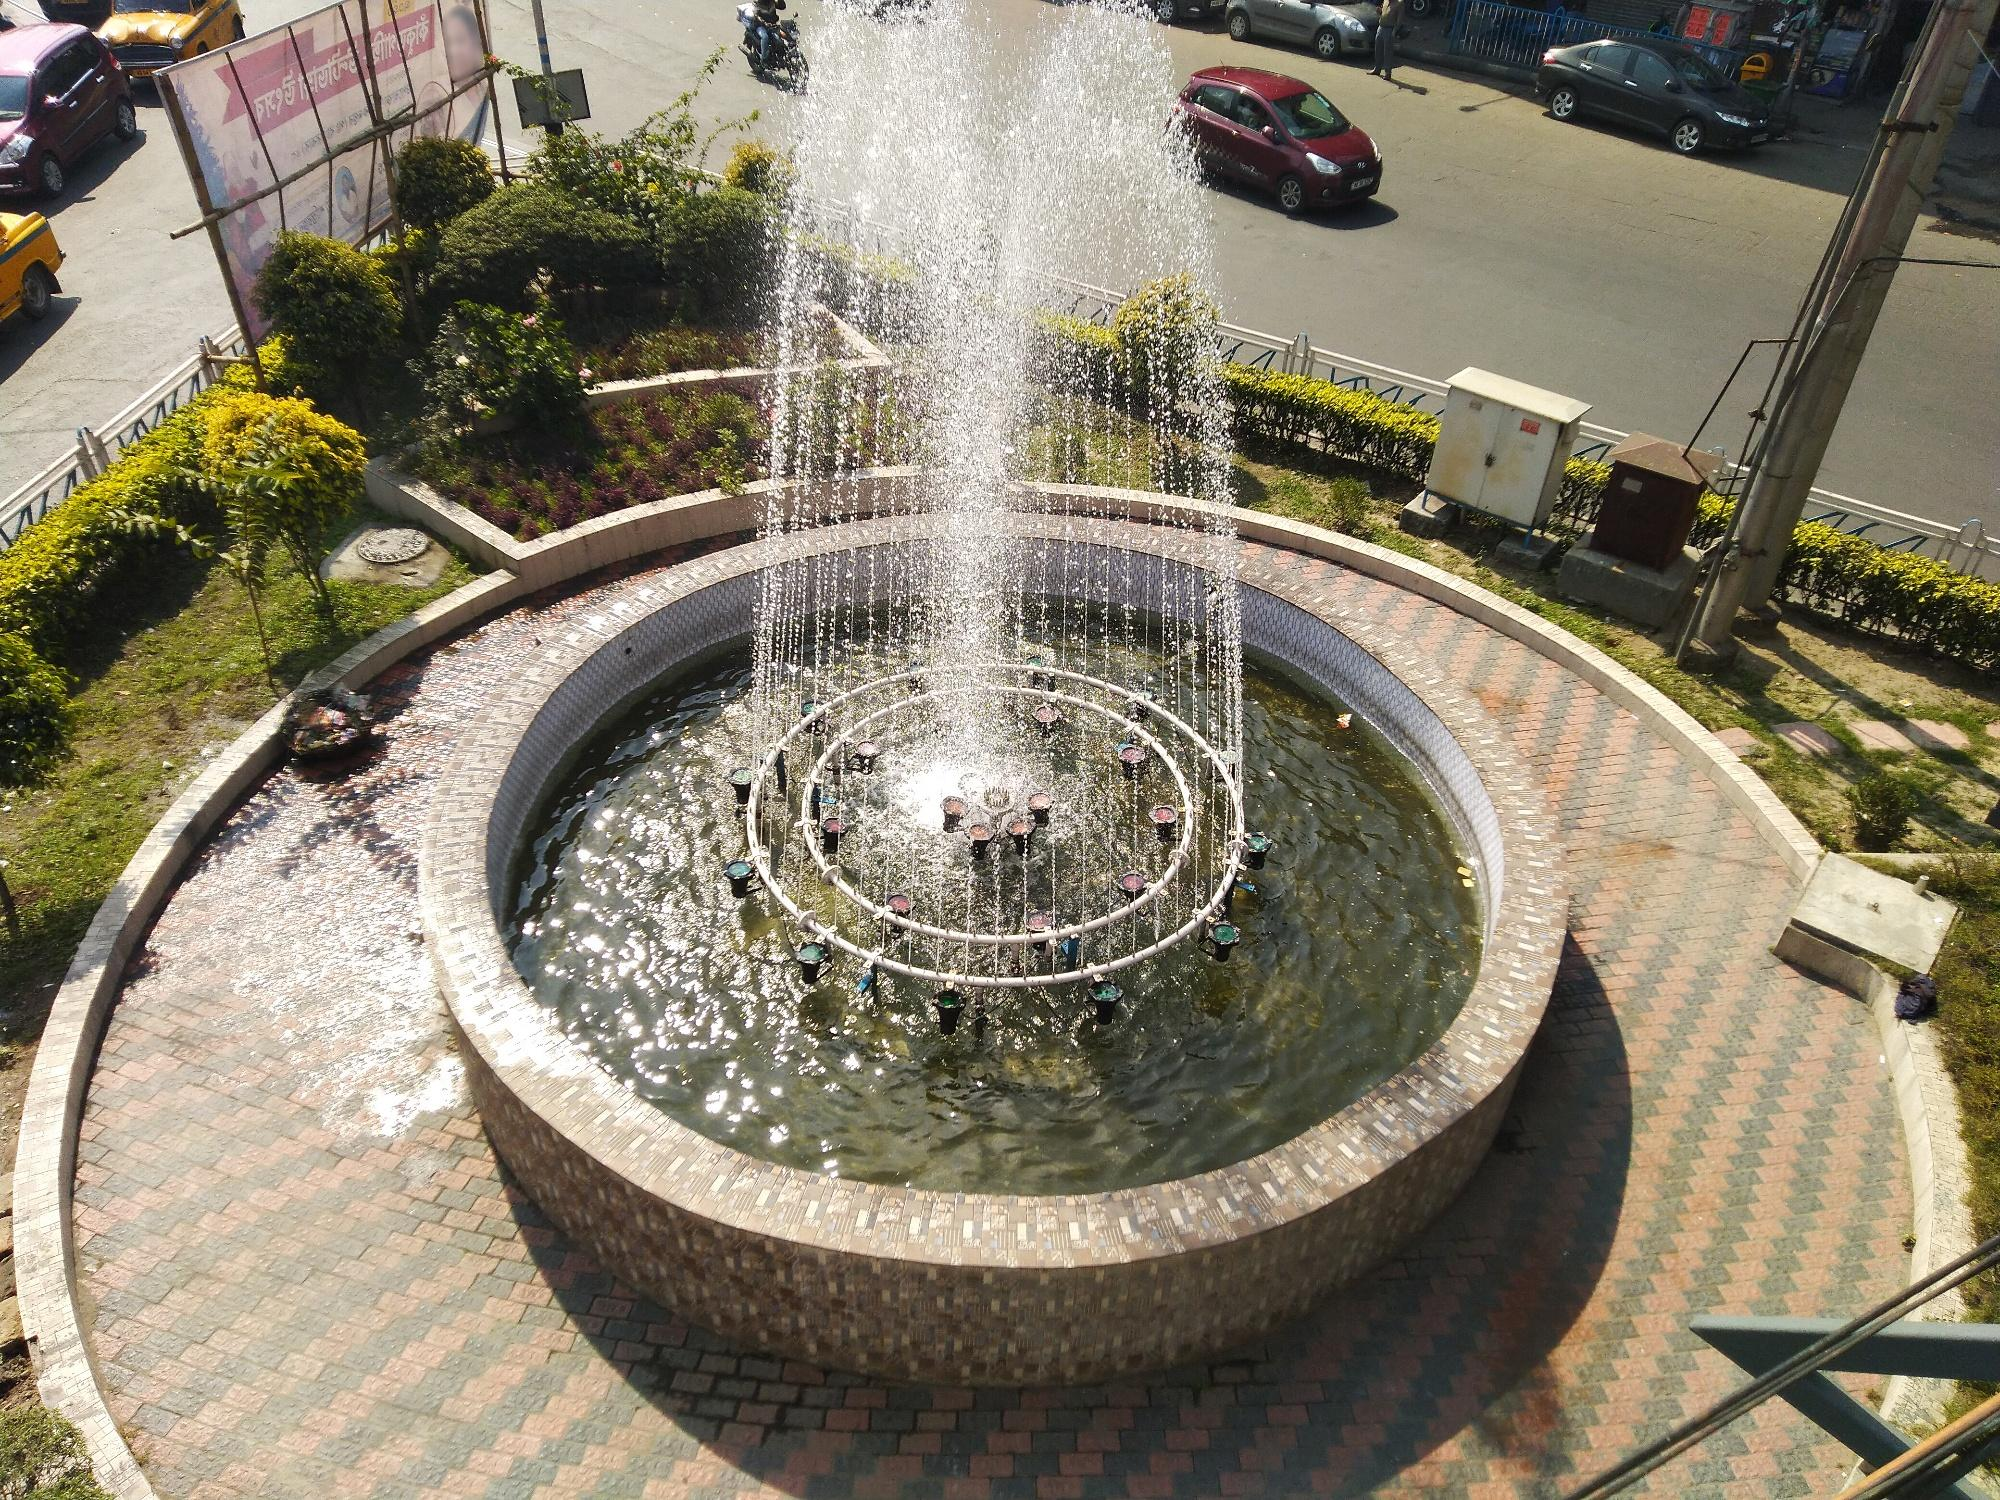If the fountain could talk, what stories would it tell? If the fountain could talk, it would share countless stories of the people who have passed by. It would tell of the lovers who sat on its edge, whispering sweet nothings, and the children who laughed in delight at the water spray. It would recount late-night serenades of street musicians, the fervent activities of city parades, and the quiet moments of introspection it has witnessed at dawn.

The fountain would speak of the seasons of change, from bustling summers to quiet, snow-covered winters. It has seen the city evolve around it, watched new generations grow up, and has been a silent witness to the ever-changing tapestry of urban life. 